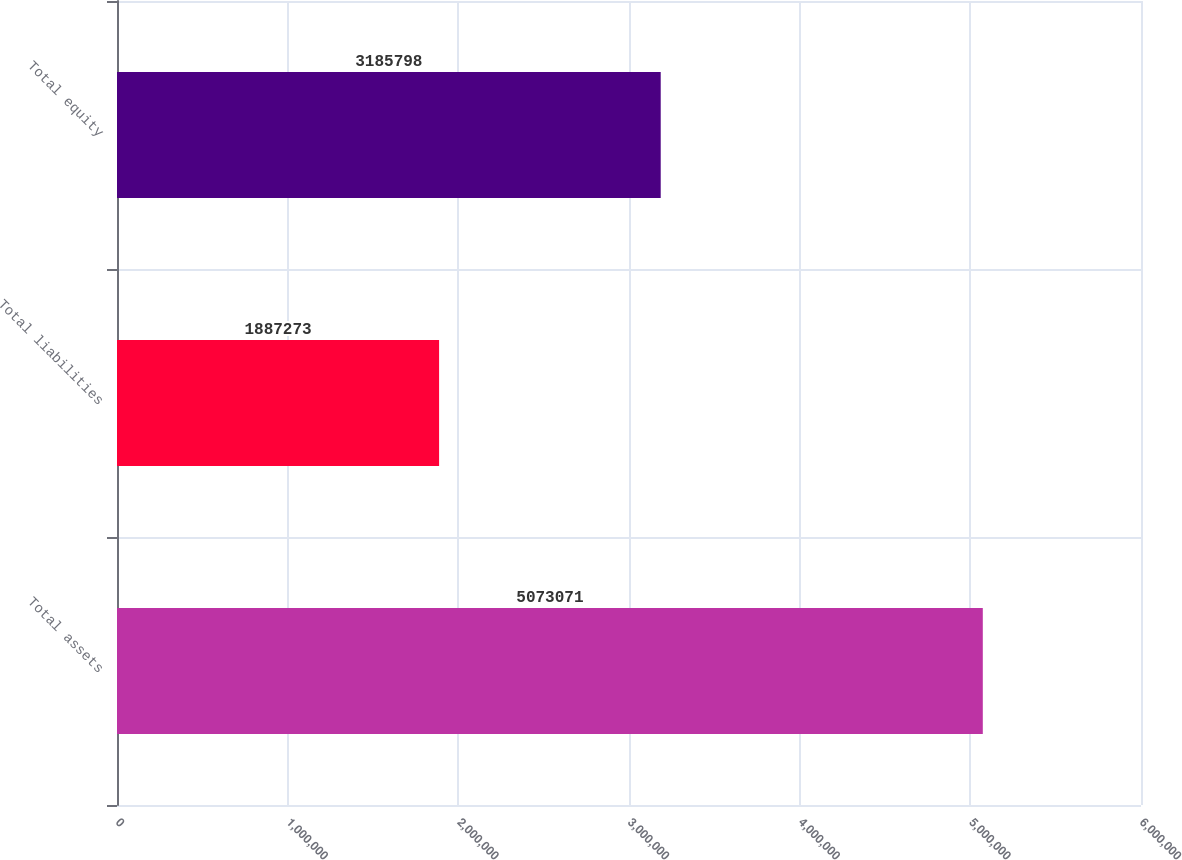<chart> <loc_0><loc_0><loc_500><loc_500><bar_chart><fcel>Total assets<fcel>Total liabilities<fcel>Total equity<nl><fcel>5.07307e+06<fcel>1.88727e+06<fcel>3.1858e+06<nl></chart> 